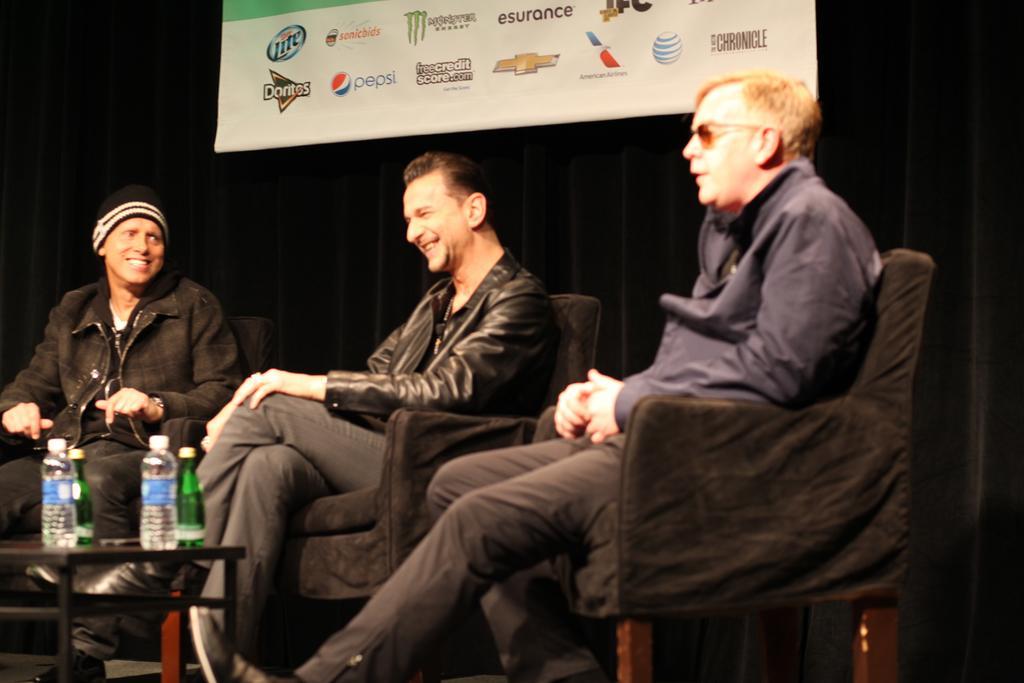Can you describe this image briefly? In the image there are three men sitting on chairs with table in front of them with water bottles on it, all of them are smiling, behind them there is a banner on the wall. 